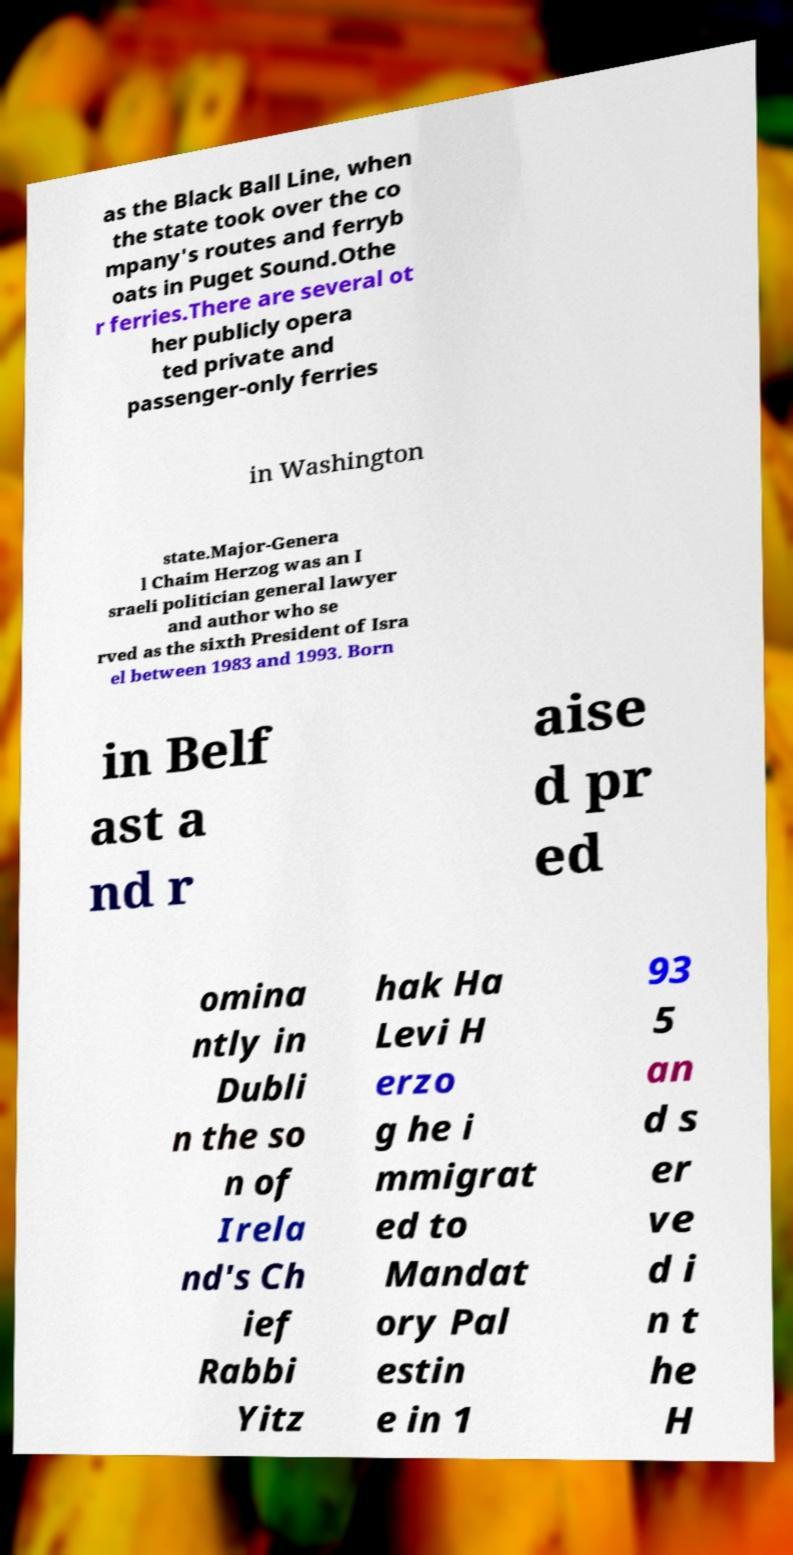I need the written content from this picture converted into text. Can you do that? as the Black Ball Line, when the state took over the co mpany's routes and ferryb oats in Puget Sound.Othe r ferries.There are several ot her publicly opera ted private and passenger-only ferries in Washington state.Major-Genera l Chaim Herzog was an I sraeli politician general lawyer and author who se rved as the sixth President of Isra el between 1983 and 1993. Born in Belf ast a nd r aise d pr ed omina ntly in Dubli n the so n of Irela nd's Ch ief Rabbi Yitz hak Ha Levi H erzo g he i mmigrat ed to Mandat ory Pal estin e in 1 93 5 an d s er ve d i n t he H 